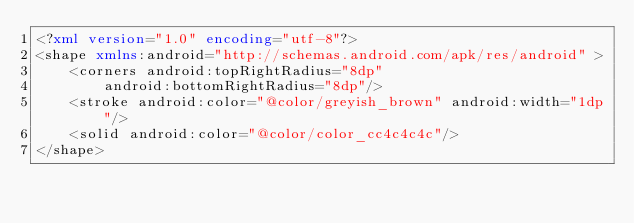Convert code to text. <code><loc_0><loc_0><loc_500><loc_500><_XML_><?xml version="1.0" encoding="utf-8"?>
<shape xmlns:android="http://schemas.android.com/apk/res/android" >
    <corners android:topRightRadius="8dp"
        android:bottomRightRadius="8dp"/>
    <stroke android:color="@color/greyish_brown" android:width="1dp"/>
    <solid android:color="@color/color_cc4c4c4c"/>
</shape></code> 